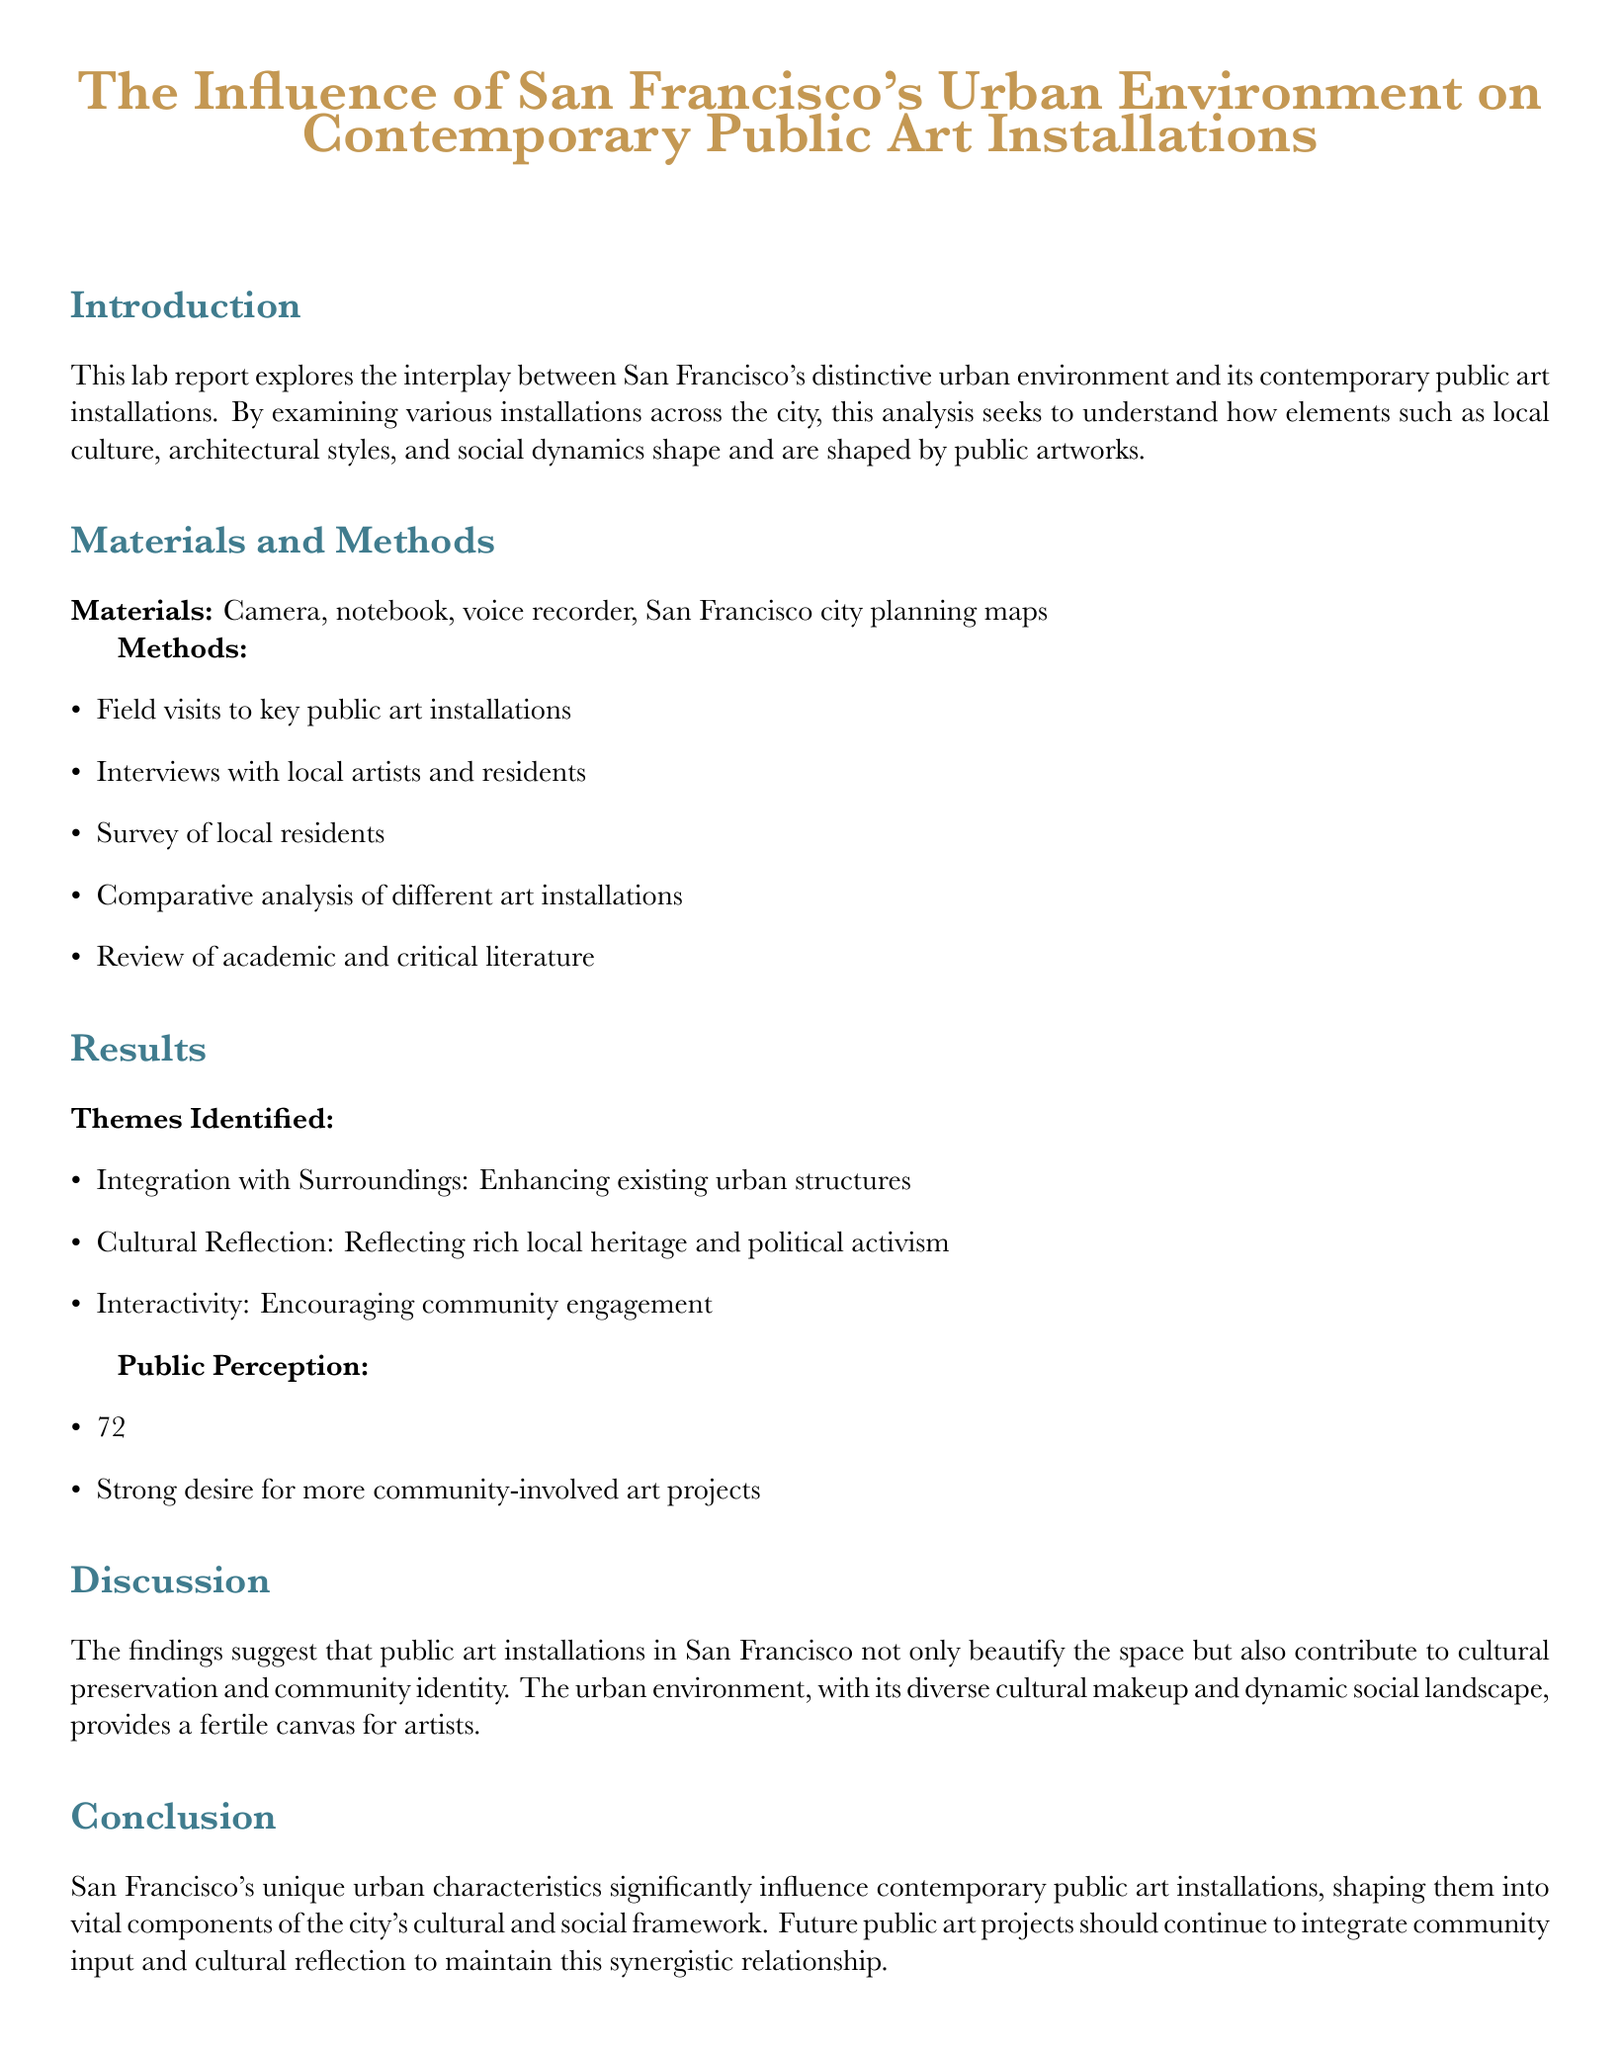what is the main focus of the lab report? The main focus of the lab report is to explore the interplay between San Francisco's urban environment and contemporary public art installations.
Answer: interplay between urban environment and public art installations how many themes were identified in the results section? The results section identified three themes related to public art installations.
Answer: three what percentage of respondents feel public art improves neighborhood aesthetics? The document states that 72% of respondents feel public art improves neighborhood aesthetics.
Answer: 72% which materials were used in the study? The materials used in the study include a camera, notebook, voice recorder, and San Francisco city planning maps.
Answer: camera, notebook, voice recorder, San Francisco city planning maps what is one of the identified themes related to public art? One of the identified themes is Cultural Reflection, which pertains to reflecting local heritage and political activism.
Answer: Cultural Reflection what conclusion is drawn about San Francisco's urban characteristics? The conclusion drawn is that San Francisco's urban characteristics significantly influence contemporary public art installations.
Answer: significantly influence contemporary public art installations how was public perception surveyed in the study? Public perception was surveyed through a survey of local residents.
Answer: survey of local residents what is encouraged by the theme of interactivity? The theme of interactivity encourages community engagement with public art installations.
Answer: community engagement 